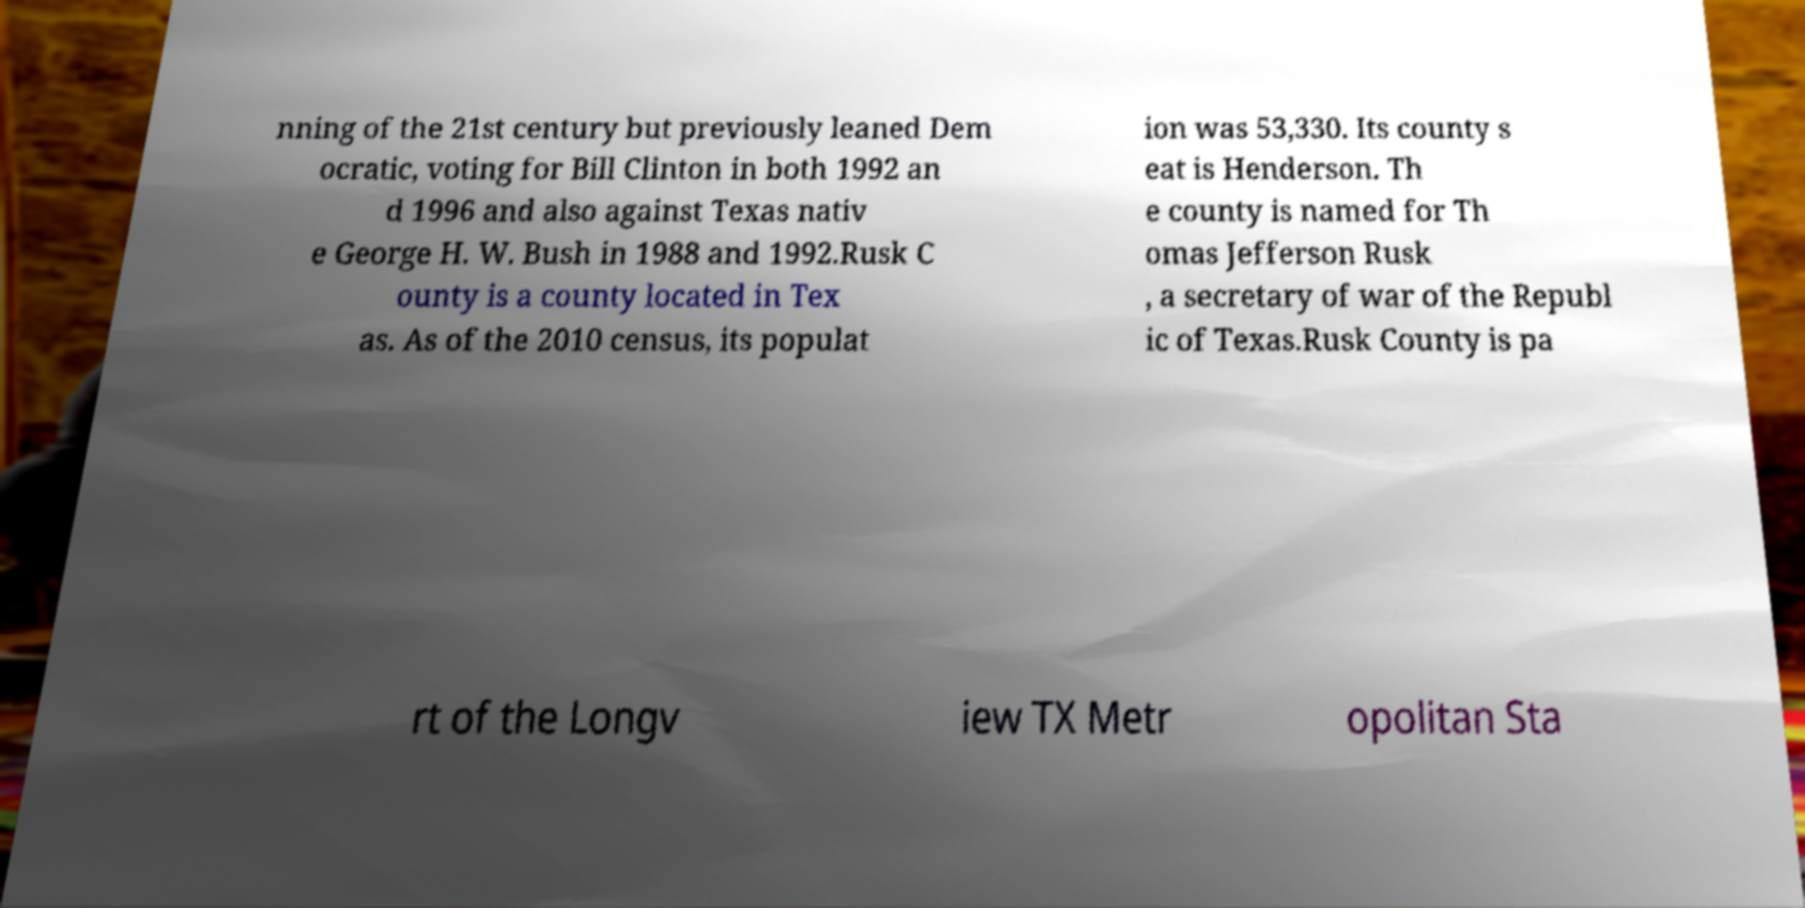What messages or text are displayed in this image? I need them in a readable, typed format. nning of the 21st century but previously leaned Dem ocratic, voting for Bill Clinton in both 1992 an d 1996 and also against Texas nativ e George H. W. Bush in 1988 and 1992.Rusk C ounty is a county located in Tex as. As of the 2010 census, its populat ion was 53,330. Its county s eat is Henderson. Th e county is named for Th omas Jefferson Rusk , a secretary of war of the Republ ic of Texas.Rusk County is pa rt of the Longv iew TX Metr opolitan Sta 